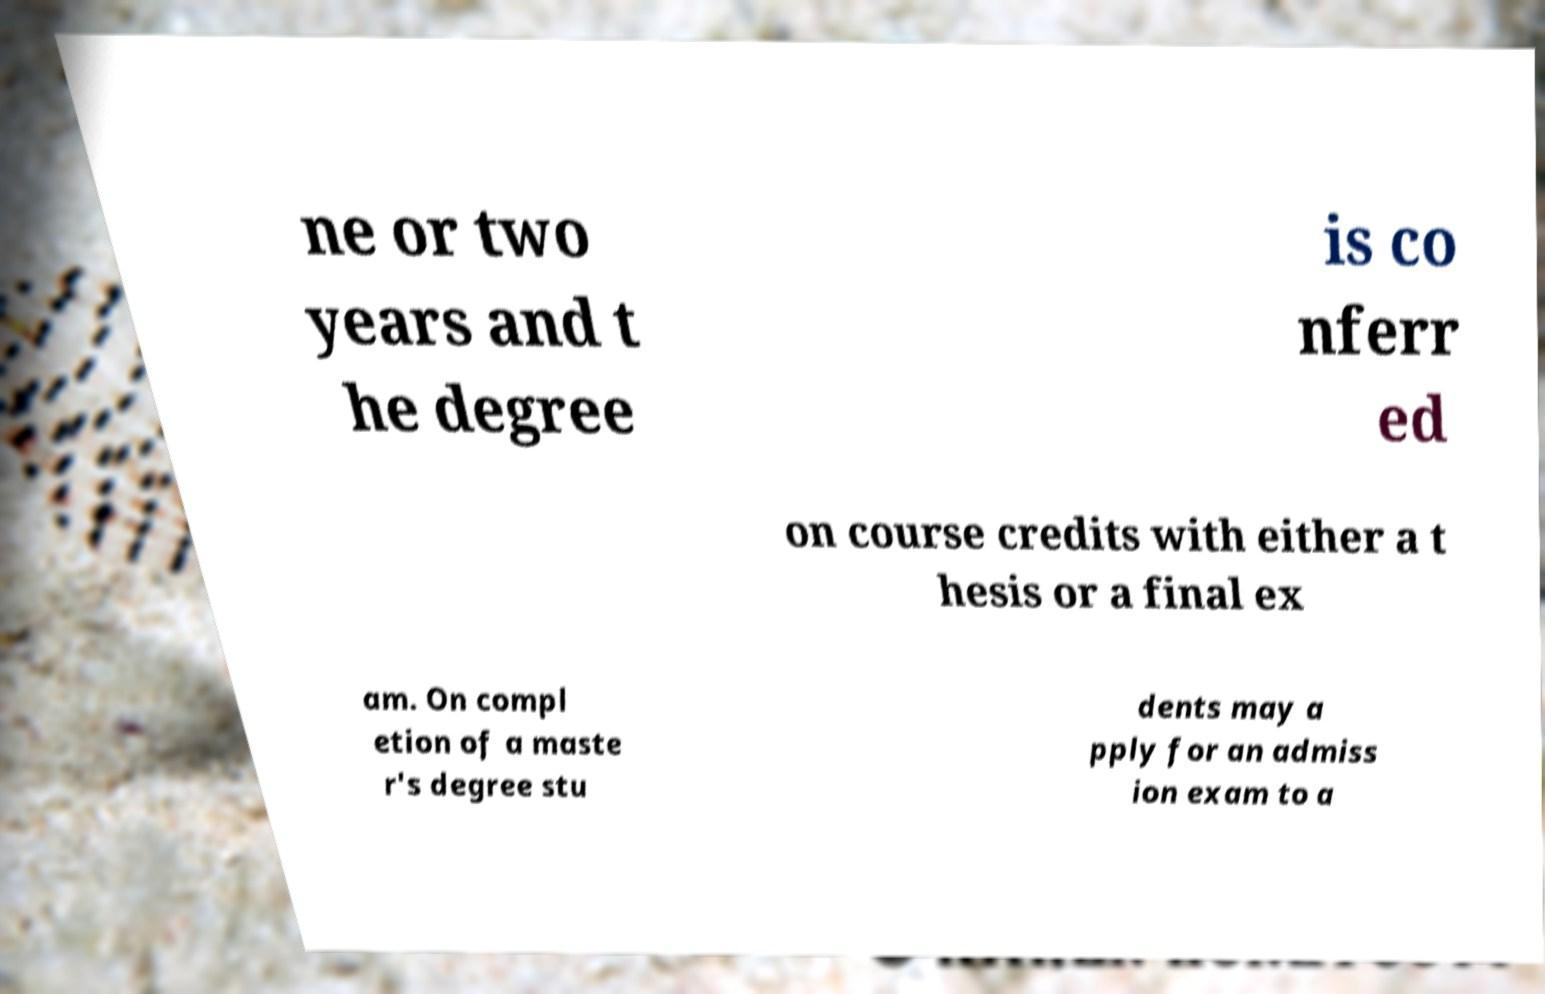Could you assist in decoding the text presented in this image and type it out clearly? ne or two years and t he degree is co nferr ed on course credits with either a t hesis or a final ex am. On compl etion of a maste r's degree stu dents may a pply for an admiss ion exam to a 